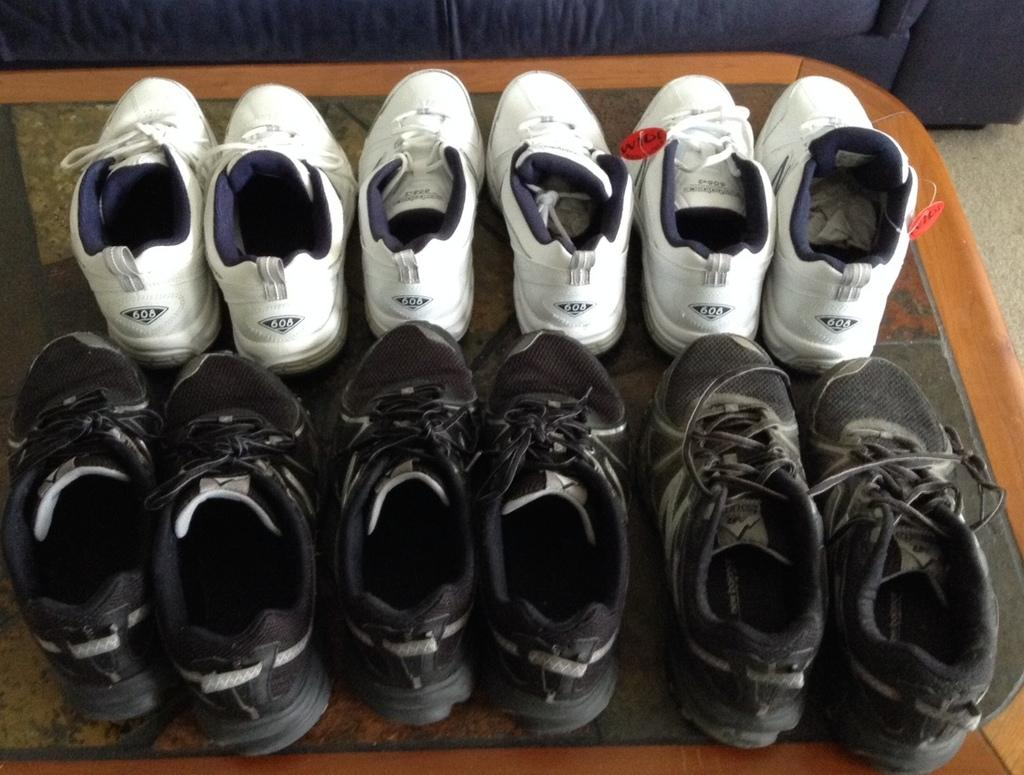What objects are grouped together in the image? There is a group of shoes in the image. Where are the shoes placed? The shoes are placed on a table. What type of furniture is visible at the top of the image? There is a sofa visible at the top of the image. What type of protest is happening in the image? There is no protest present in the image; it features a group of shoes placed on a table and a sofa visible at the top. 